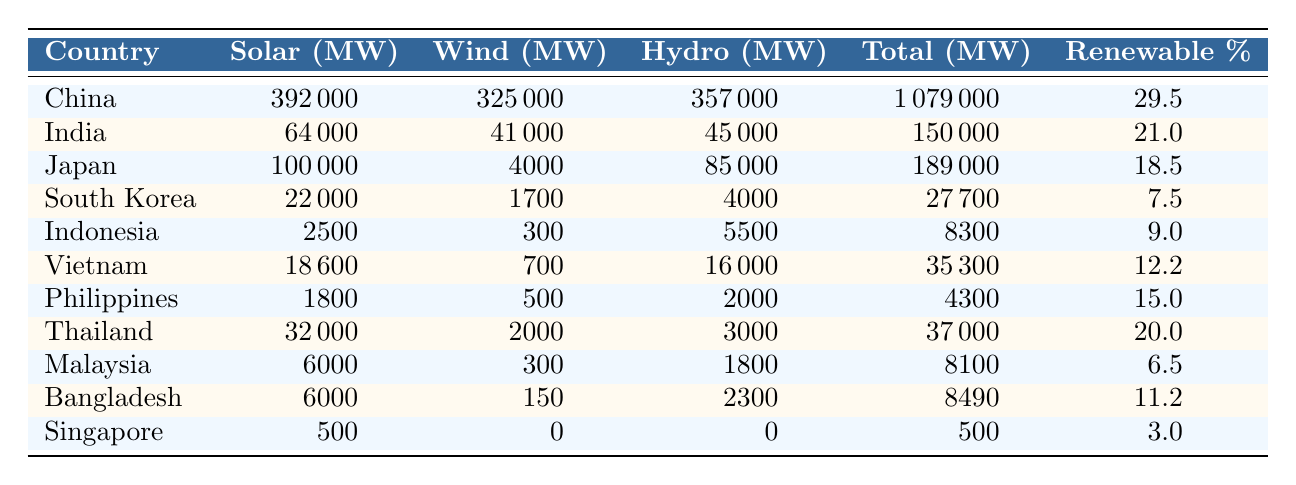What country has the highest solar capacity in megawatts? Referring to the table, China has a solar capacity of 392,000 MW, which is the highest among all countries listed.
Answer: China Which country has the lowest renewable energy adoption percentage? By checking the renewable percentage column, Singapore shows the lowest adoption rate of 3.0%.
Answer: Singapore What is the total renewable capacity for India? The table states that India's total renewable capacity is 150,000 MW.
Answer: 150,000 MW Which countries have a renewable energy adoption rate above 20%? Looking at the renewable percentage column, the countries with rates above 20% are China (29.5%) and India (21.0%).
Answer: China, India What is the combined solar capacity of Vietnam and Thailand? Vietnam's solar capacity is 18,600 MW, and Thailand's is 32,000 MW. Summing these gives 18,600 + 32,000 = 50,600 MW.
Answer: 50,600 MW Is Japan's hydro capacity greater than that of South Korea? Japan's hydro capacity is 85,000 MW, while South Korea's is 4,000 MW, so yes, Japan's hydro capacity is greater.
Answer: Yes What is the average renewable adoption rate of the listed countries? To find the average, sum all the renewable percentages (29.5 + 21.0 + 18.5 + 7.5 + 9.0 + 12.2 + 15.0 + 20.0 + 6.5 + 11.2 + 3.0 = 152.4) and divide by the number of countries (11). The average is 152.4 / 11 ≈ 13.87%.
Answer: 13.87% Which country has a total renewable capacity of less than 10,000 MW? From the table, both Indonesia (8,300 MW) and Malaysia (8,100 MW) have total renewable capacities under 10,000 MW.
Answer: Indonesia, Malaysia What is the difference in total renewable capacity between China and Japan? China's total renewable capacity is 1,079,000 MW, and Japan's is 189,000 MW. The difference is 1,079,000 - 189,000 = 890,000 MW.
Answer: 890,000 MW Which country has a higher wind capacity: India or Japan? India has a wind capacity of 41,000 MW, while Japan has 4,000 MW. Since 41,000 MW is greater than 4,000 MW, India has a higher wind capacity.
Answer: India 